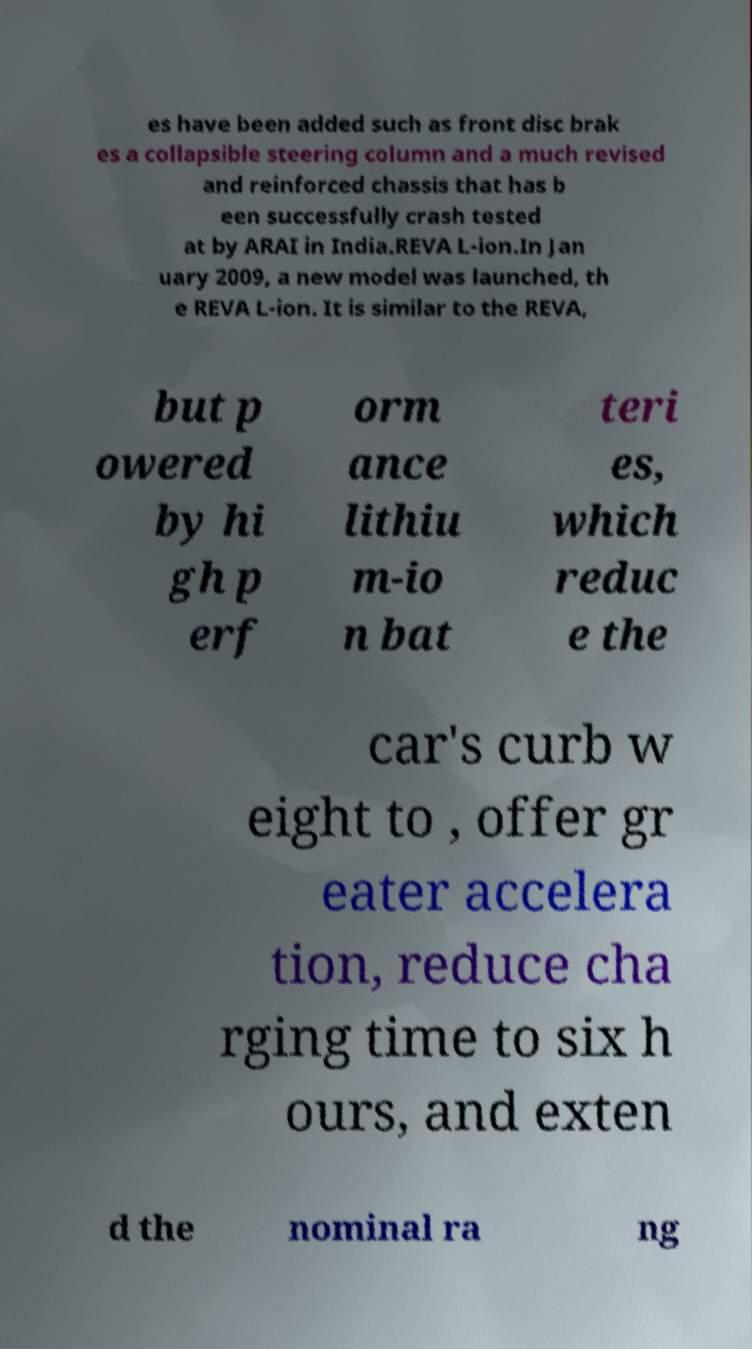For documentation purposes, I need the text within this image transcribed. Could you provide that? es have been added such as front disc brak es a collapsible steering column and a much revised and reinforced chassis that has b een successfully crash tested at by ARAI in India.REVA L-ion.In Jan uary 2009, a new model was launched, th e REVA L-ion. It is similar to the REVA, but p owered by hi gh p erf orm ance lithiu m-io n bat teri es, which reduc e the car's curb w eight to , offer gr eater accelera tion, reduce cha rging time to six h ours, and exten d the nominal ra ng 